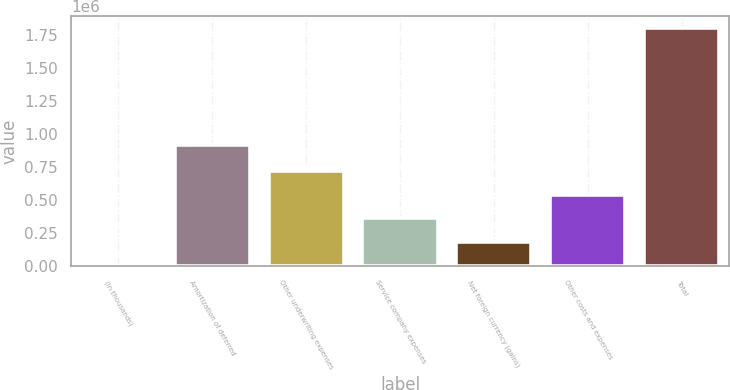Convert chart to OTSL. <chart><loc_0><loc_0><loc_500><loc_500><bar_chart><fcel>(In thousands)<fcel>Amortization of deferred<fcel>Other underwriting expenses<fcel>Service company expenses<fcel>Net foreign currency (gains)<fcel>Other costs and expenses<fcel>Total<nl><fcel>2012<fcel>917583<fcel>721056<fcel>361534<fcel>181773<fcel>541295<fcel>1.79962e+06<nl></chart> 